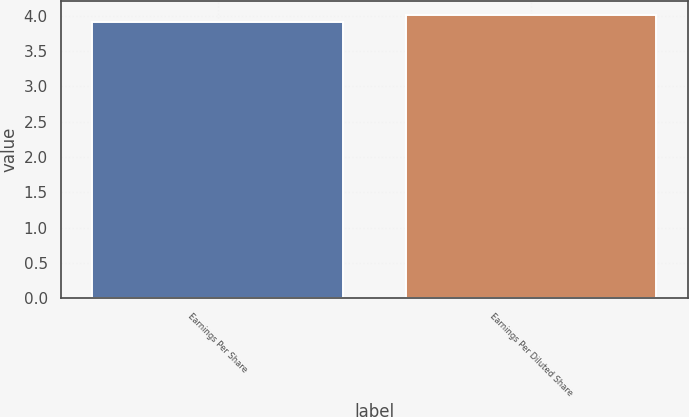Convert chart. <chart><loc_0><loc_0><loc_500><loc_500><bar_chart><fcel>Earnings Per Share<fcel>Earnings Per Diluted Share<nl><fcel>3.91<fcel>4.01<nl></chart> 